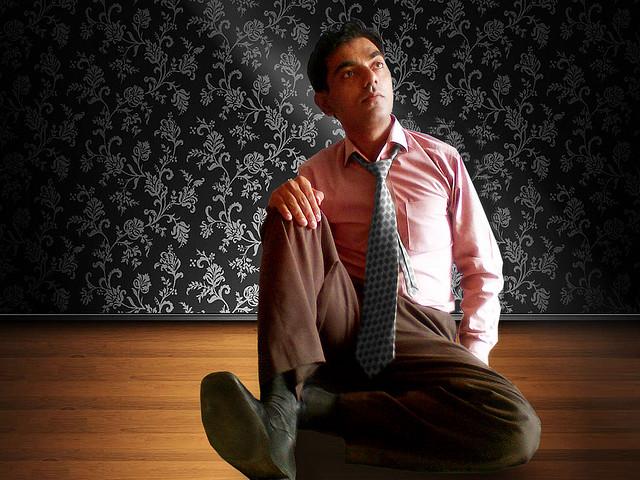Why are the edges of this photograph dark?
Keep it brief. Lighting. What is he looking at?
Answer briefly. Wall. What color is the man's shirt?
Concise answer only. Pink. 